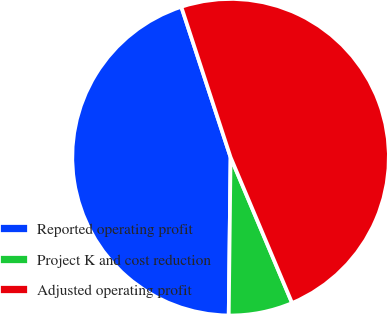Convert chart. <chart><loc_0><loc_0><loc_500><loc_500><pie_chart><fcel>Reported operating profit<fcel>Project K and cost reduction<fcel>Adjusted operating profit<nl><fcel>44.77%<fcel>6.54%<fcel>48.68%<nl></chart> 